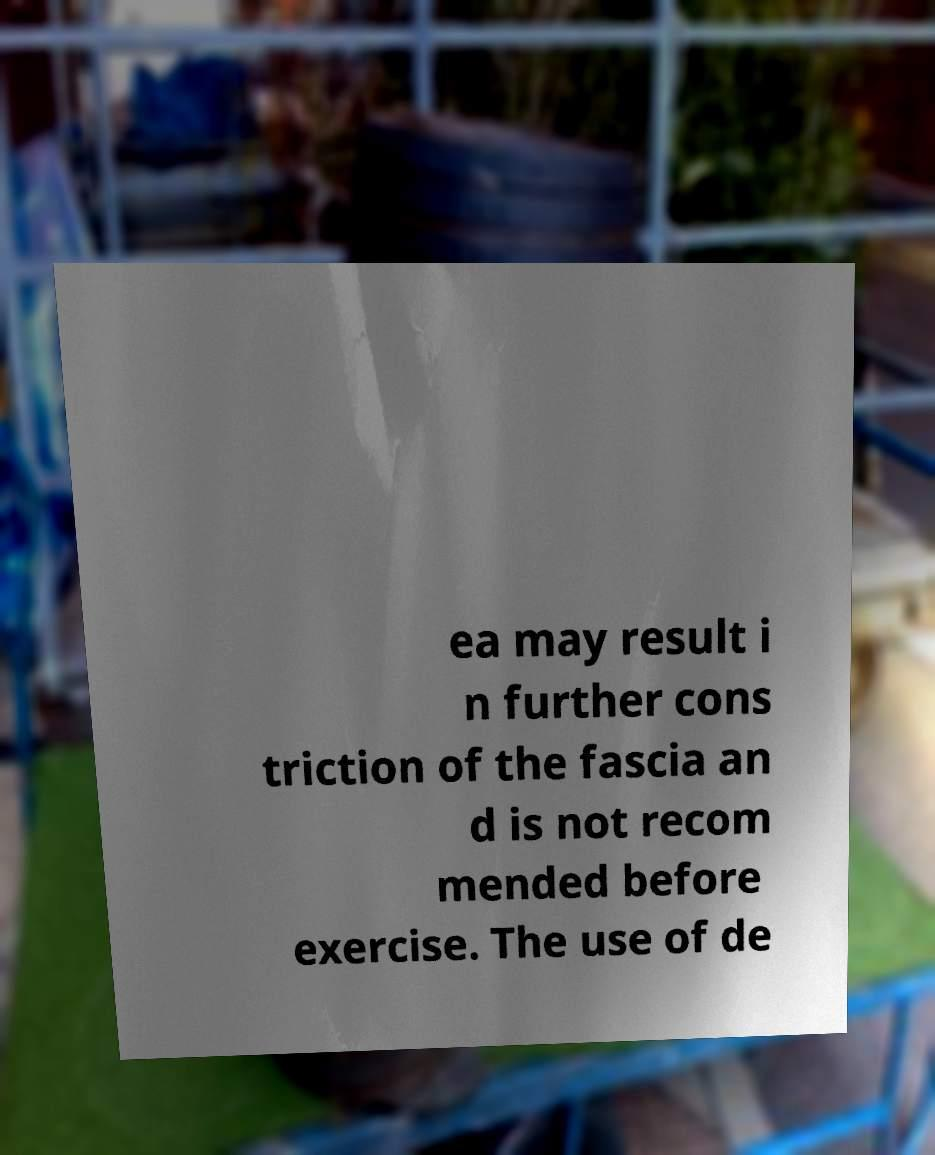I need the written content from this picture converted into text. Can you do that? ea may result i n further cons triction of the fascia an d is not recom mended before exercise. The use of de 